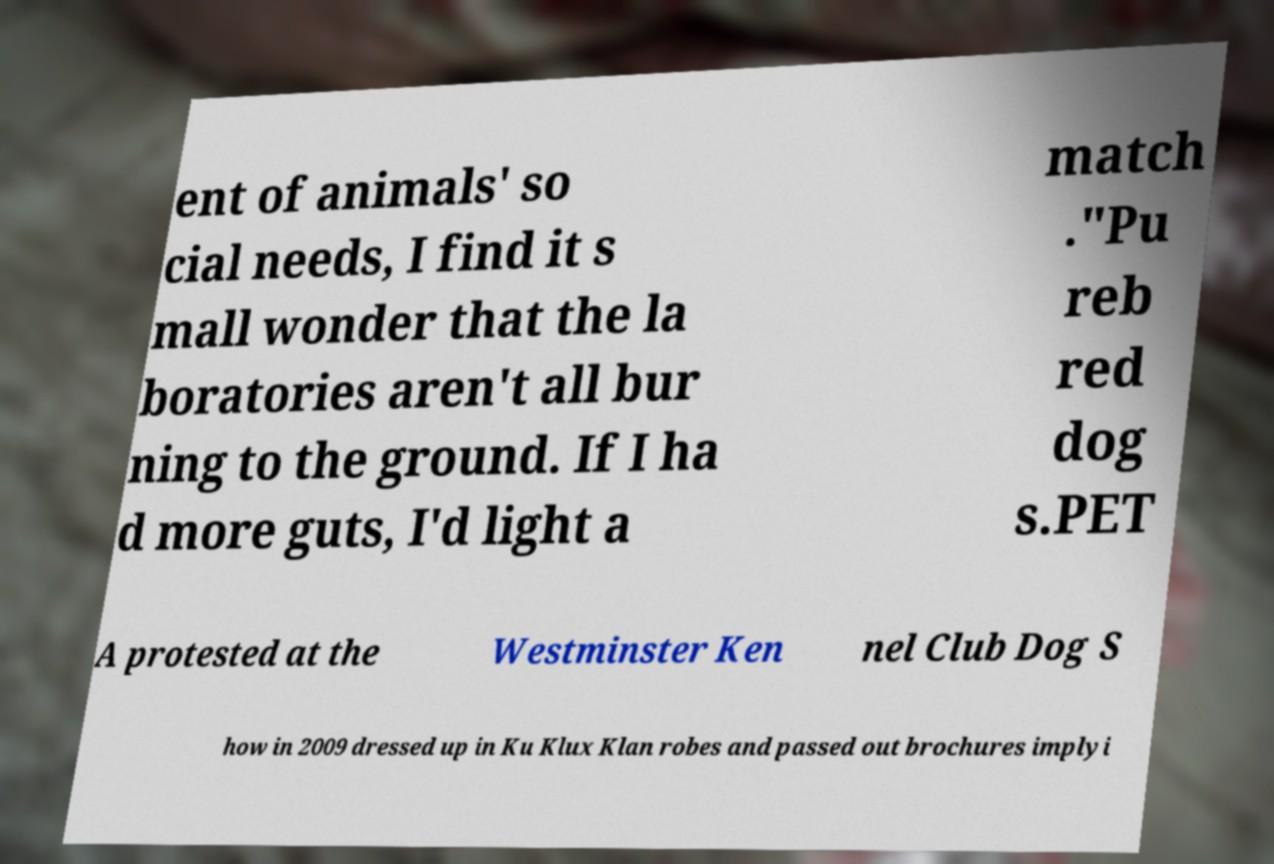Could you assist in decoding the text presented in this image and type it out clearly? ent of animals' so cial needs, I find it s mall wonder that the la boratories aren't all bur ning to the ground. If I ha d more guts, I'd light a match ."Pu reb red dog s.PET A protested at the Westminster Ken nel Club Dog S how in 2009 dressed up in Ku Klux Klan robes and passed out brochures implyi 